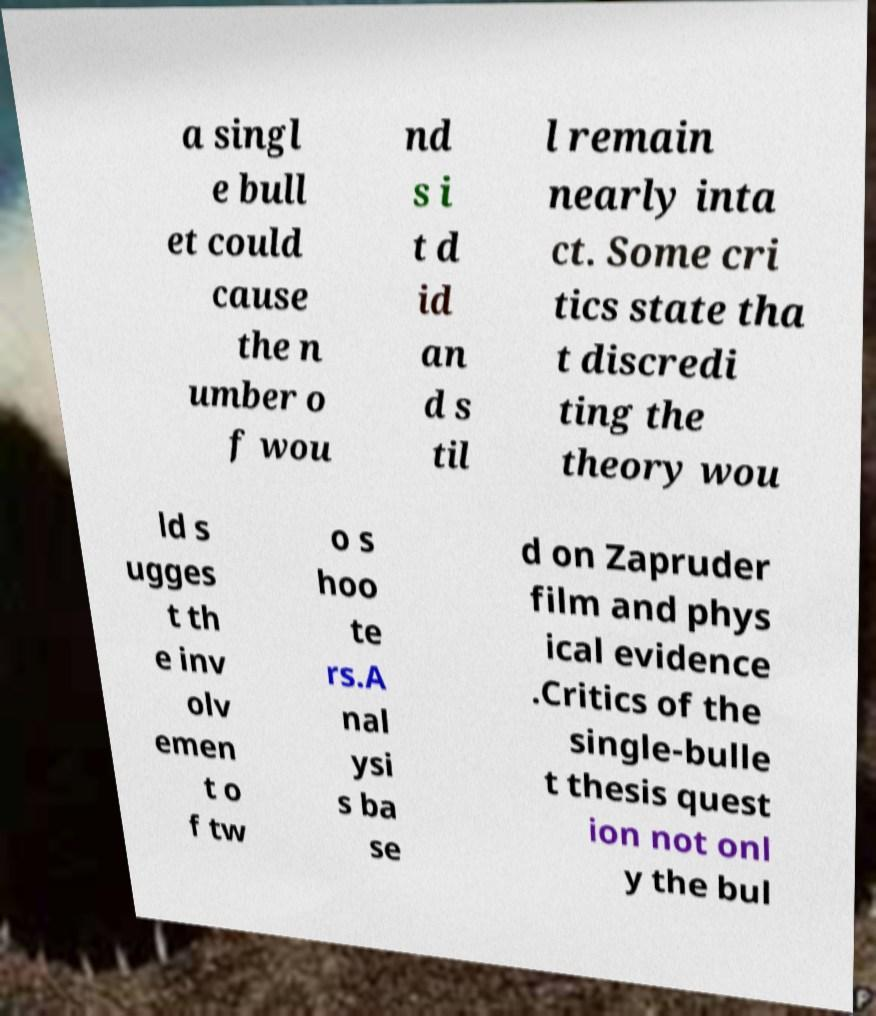Can you read and provide the text displayed in the image?This photo seems to have some interesting text. Can you extract and type it out for me? a singl e bull et could cause the n umber o f wou nd s i t d id an d s til l remain nearly inta ct. Some cri tics state tha t discredi ting the theory wou ld s ugges t th e inv olv emen t o f tw o s hoo te rs.A nal ysi s ba se d on Zapruder film and phys ical evidence .Critics of the single-bulle t thesis quest ion not onl y the bul 